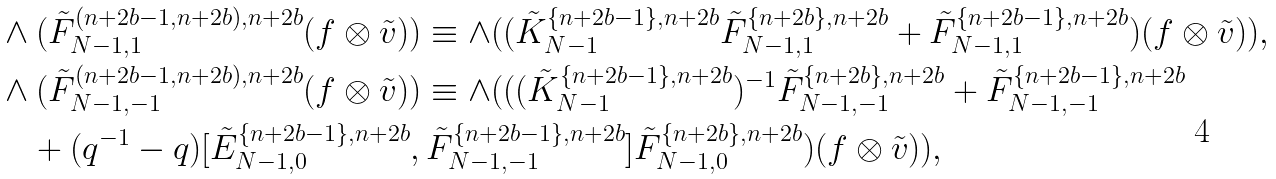Convert formula to latex. <formula><loc_0><loc_0><loc_500><loc_500>& \wedge ( \tilde { F } ^ { ( n + 2 b - 1 , n + 2 b ) , n + 2 b } _ { N - 1 , 1 } ( f \otimes \tilde { v } ) ) \equiv \wedge ( ( \tilde { K } _ { N - 1 } ^ { \{ n + 2 b - 1 \} , n + 2 b } \tilde { F } _ { N - 1 , 1 } ^ { \{ n + 2 b \} , n + 2 b } + \tilde { F } _ { N - 1 , 1 } ^ { \{ n + 2 b - 1 \} , n + 2 b } ) ( f \otimes \tilde { v } ) ) , \\ & \wedge ( \tilde { F } ^ { ( n + 2 b - 1 , n + 2 b ) , n + 2 b } _ { N - 1 , - 1 } ( f \otimes \tilde { v } ) ) \equiv \wedge ( ( ( \tilde { K } _ { N - 1 } ^ { \{ n + 2 b - 1 \} , n + 2 b } ) ^ { - 1 } \tilde { F } _ { N - 1 , - 1 } ^ { \{ n + 2 b \} , n + 2 b } + \tilde { F } _ { N - 1 , - 1 } ^ { \{ n + 2 b - 1 \} , n + 2 b } \\ & \quad + ( q ^ { - 1 } - q ) [ \tilde { E } _ { N - 1 , 0 } ^ { \{ n + 2 b - 1 \} , n + 2 b } , \tilde { F } _ { N - 1 , - 1 } ^ { \{ n + 2 b - 1 \} , n + 2 b } ] \tilde { F } _ { N - 1 , 0 } ^ { \{ n + 2 b \} , n + 2 b } ) ( f \otimes \tilde { v } ) ) ,</formula> 